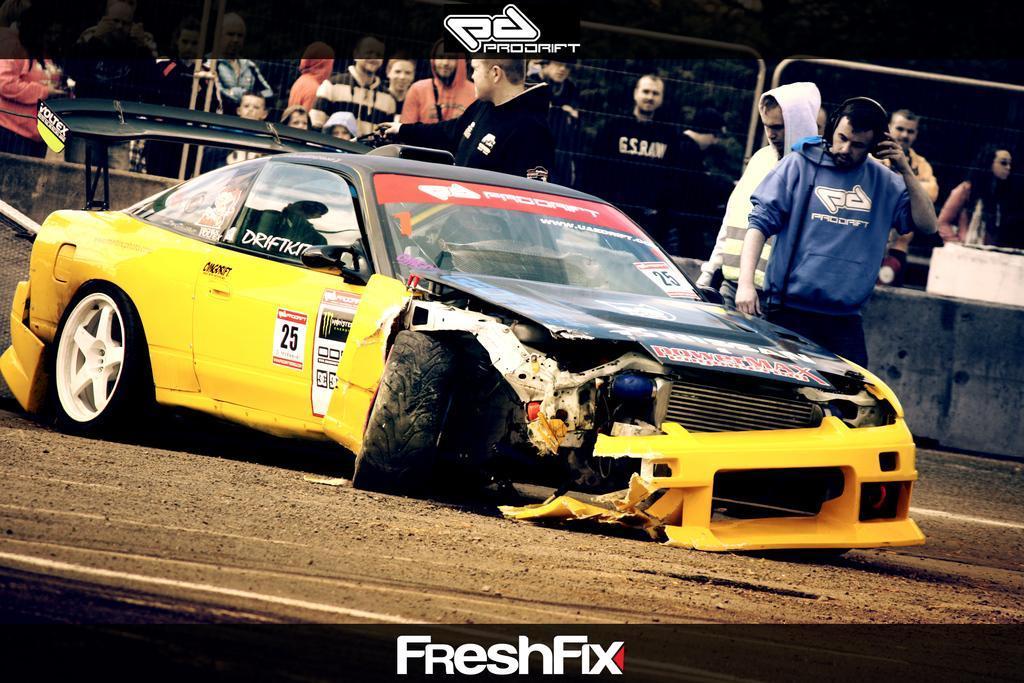Can you describe this image briefly? In this picture I can see few people standing and I can see a car and text at the top and at the bottom of the picture. 